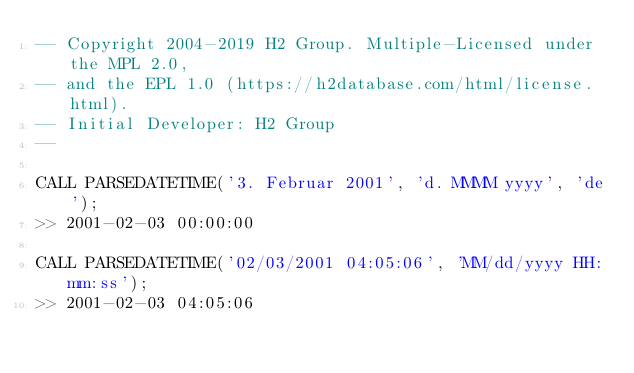<code> <loc_0><loc_0><loc_500><loc_500><_SQL_>-- Copyright 2004-2019 H2 Group. Multiple-Licensed under the MPL 2.0,
-- and the EPL 1.0 (https://h2database.com/html/license.html).
-- Initial Developer: H2 Group
--

CALL PARSEDATETIME('3. Februar 2001', 'd. MMMM yyyy', 'de');
>> 2001-02-03 00:00:00

CALL PARSEDATETIME('02/03/2001 04:05:06', 'MM/dd/yyyy HH:mm:ss');
>> 2001-02-03 04:05:06
</code> 